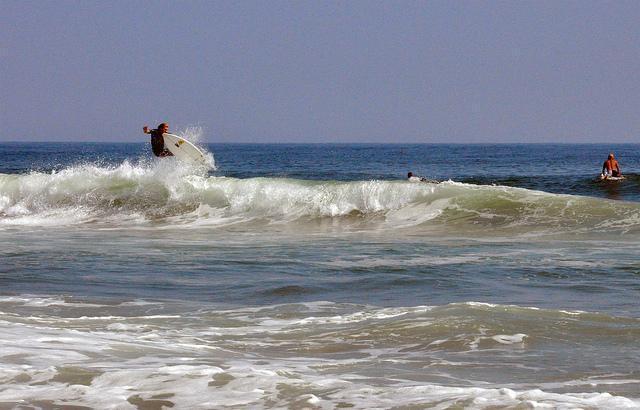How many people are in the water?
Give a very brief answer. 2. 